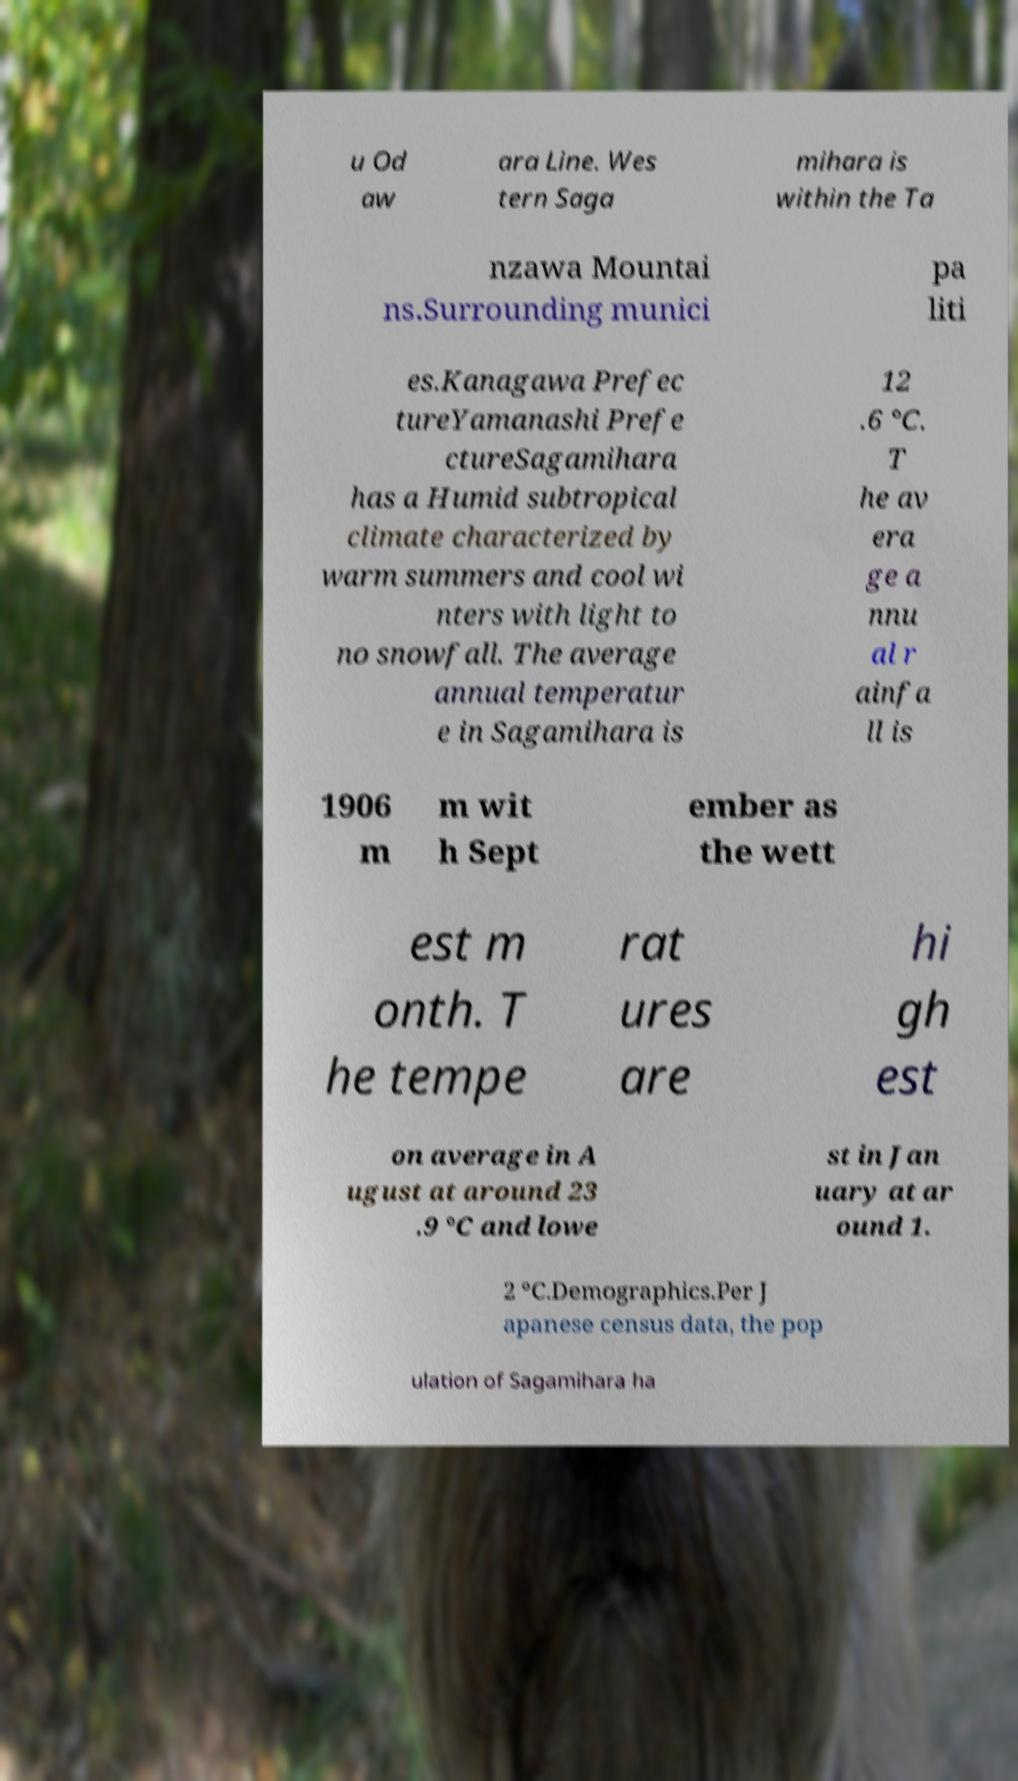Could you extract and type out the text from this image? u Od aw ara Line. Wes tern Saga mihara is within the Ta nzawa Mountai ns.Surrounding munici pa liti es.Kanagawa Prefec tureYamanashi Prefe ctureSagamihara has a Humid subtropical climate characterized by warm summers and cool wi nters with light to no snowfall. The average annual temperatur e in Sagamihara is 12 .6 °C. T he av era ge a nnu al r ainfa ll is 1906 m m wit h Sept ember as the wett est m onth. T he tempe rat ures are hi gh est on average in A ugust at around 23 .9 °C and lowe st in Jan uary at ar ound 1. 2 °C.Demographics.Per J apanese census data, the pop ulation of Sagamihara ha 